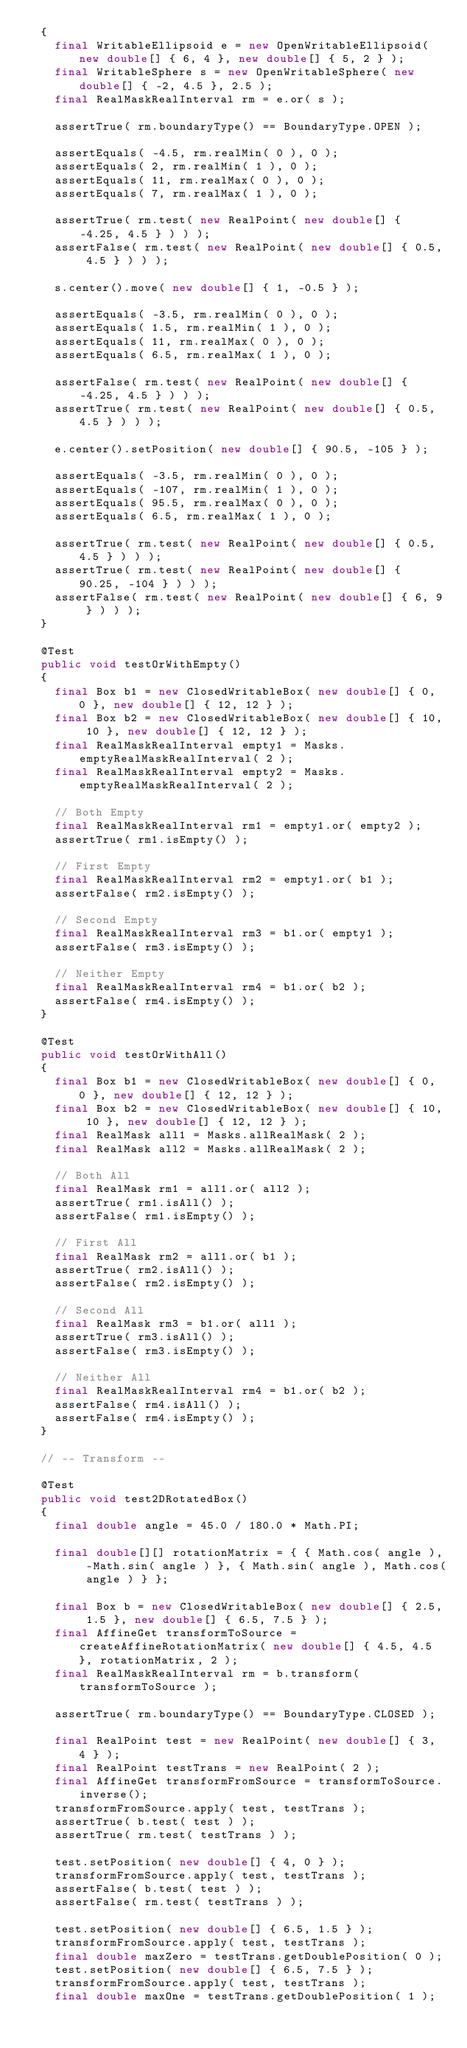<code> <loc_0><loc_0><loc_500><loc_500><_Java_>	{
		final WritableEllipsoid e = new OpenWritableEllipsoid( new double[] { 6, 4 }, new double[] { 5, 2 } );
		final WritableSphere s = new OpenWritableSphere( new double[] { -2, 4.5 }, 2.5 );
		final RealMaskRealInterval rm = e.or( s );

		assertTrue( rm.boundaryType() == BoundaryType.OPEN );

		assertEquals( -4.5, rm.realMin( 0 ), 0 );
		assertEquals( 2, rm.realMin( 1 ), 0 );
		assertEquals( 11, rm.realMax( 0 ), 0 );
		assertEquals( 7, rm.realMax( 1 ), 0 );

		assertTrue( rm.test( new RealPoint( new double[] { -4.25, 4.5 } ) ) );
		assertFalse( rm.test( new RealPoint( new double[] { 0.5, 4.5 } ) ) );

		s.center().move( new double[] { 1, -0.5 } );

		assertEquals( -3.5, rm.realMin( 0 ), 0 );
		assertEquals( 1.5, rm.realMin( 1 ), 0 );
		assertEquals( 11, rm.realMax( 0 ), 0 );
		assertEquals( 6.5, rm.realMax( 1 ), 0 );

		assertFalse( rm.test( new RealPoint( new double[] { -4.25, 4.5 } ) ) );
		assertTrue( rm.test( new RealPoint( new double[] { 0.5, 4.5 } ) ) );

		e.center().setPosition( new double[] { 90.5, -105 } );

		assertEquals( -3.5, rm.realMin( 0 ), 0 );
		assertEquals( -107, rm.realMin( 1 ), 0 );
		assertEquals( 95.5, rm.realMax( 0 ), 0 );
		assertEquals( 6.5, rm.realMax( 1 ), 0 );

		assertTrue( rm.test( new RealPoint( new double[] { 0.5, 4.5 } ) ) );
		assertTrue( rm.test( new RealPoint( new double[] { 90.25, -104 } ) ) );
		assertFalse( rm.test( new RealPoint( new double[] { 6, 9 } ) ) );
	}

	@Test
	public void testOrWithEmpty()
	{
		final Box b1 = new ClosedWritableBox( new double[] { 0, 0 }, new double[] { 12, 12 } );
		final Box b2 = new ClosedWritableBox( new double[] { 10, 10 }, new double[] { 12, 12 } );
		final RealMaskRealInterval empty1 = Masks.emptyRealMaskRealInterval( 2 );
		final RealMaskRealInterval empty2 = Masks.emptyRealMaskRealInterval( 2 );

		// Both Empty
		final RealMaskRealInterval rm1 = empty1.or( empty2 );
		assertTrue( rm1.isEmpty() );

		// First Empty
		final RealMaskRealInterval rm2 = empty1.or( b1 );
		assertFalse( rm2.isEmpty() );

		// Second Empty
		final RealMaskRealInterval rm3 = b1.or( empty1 );
		assertFalse( rm3.isEmpty() );

		// Neither Empty
		final RealMaskRealInterval rm4 = b1.or( b2 );
		assertFalse( rm4.isEmpty() );
	}

	@Test
	public void testOrWithAll()
	{
		final Box b1 = new ClosedWritableBox( new double[] { 0, 0 }, new double[] { 12, 12 } );
		final Box b2 = new ClosedWritableBox( new double[] { 10, 10 }, new double[] { 12, 12 } );
		final RealMask all1 = Masks.allRealMask( 2 );
		final RealMask all2 = Masks.allRealMask( 2 );

		// Both All
		final RealMask rm1 = all1.or( all2 );
		assertTrue( rm1.isAll() );
		assertFalse( rm1.isEmpty() );

		// First All
		final RealMask rm2 = all1.or( b1 );
		assertTrue( rm2.isAll() );
		assertFalse( rm2.isEmpty() );

		// Second All
		final RealMask rm3 = b1.or( all1 );
		assertTrue( rm3.isAll() );
		assertFalse( rm3.isEmpty() );

		// Neither All
		final RealMaskRealInterval rm4 = b1.or( b2 );
		assertFalse( rm4.isAll() );
		assertFalse( rm4.isEmpty() );
	}

	// -- Transform --

	@Test
	public void test2DRotatedBox()
	{
		final double angle = 45.0 / 180.0 * Math.PI;

		final double[][] rotationMatrix = { { Math.cos( angle ), -Math.sin( angle ) }, { Math.sin( angle ), Math.cos( angle ) } };

		final Box b = new ClosedWritableBox( new double[] { 2.5, 1.5 }, new double[] { 6.5, 7.5 } );
		final AffineGet transformToSource = createAffineRotationMatrix( new double[] { 4.5, 4.5 }, rotationMatrix, 2 );
		final RealMaskRealInterval rm = b.transform( transformToSource );

		assertTrue( rm.boundaryType() == BoundaryType.CLOSED );

		final RealPoint test = new RealPoint( new double[] { 3, 4 } );
		final RealPoint testTrans = new RealPoint( 2 );
		final AffineGet transformFromSource = transformToSource.inverse();
		transformFromSource.apply( test, testTrans );
		assertTrue( b.test( test ) );
		assertTrue( rm.test( testTrans ) );

		test.setPosition( new double[] { 4, 0 } );
		transformFromSource.apply( test, testTrans );
		assertFalse( b.test( test ) );
		assertFalse( rm.test( testTrans ) );

		test.setPosition( new double[] { 6.5, 1.5 } );
		transformFromSource.apply( test, testTrans );
		final double maxZero = testTrans.getDoublePosition( 0 );
		test.setPosition( new double[] { 6.5, 7.5 } );
		transformFromSource.apply( test, testTrans );
		final double maxOne = testTrans.getDoublePosition( 1 );</code> 